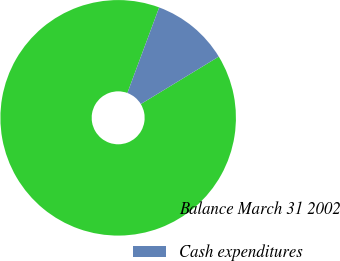Convert chart. <chart><loc_0><loc_0><loc_500><loc_500><pie_chart><fcel>Balance March 31 2002<fcel>Cash expenditures<nl><fcel>89.36%<fcel>10.64%<nl></chart> 